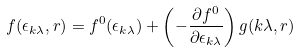Convert formula to latex. <formula><loc_0><loc_0><loc_500><loc_500>f ( \epsilon _ { { k } \lambda } , { r } ) = f ^ { 0 } ( \epsilon _ { { k } \lambda } ) + \left ( - \frac { \partial f ^ { 0 } } { \partial \epsilon _ { { k } \lambda } } \right ) g ( { k } \lambda , { r } )</formula> 